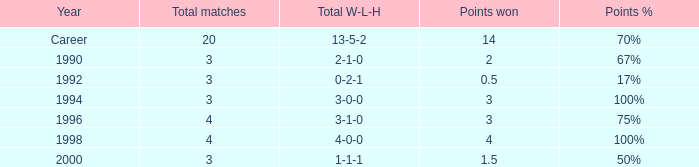Can you tell me the lowest Total natches that has the Points won of 3, and the Year of 1994? 3.0. 